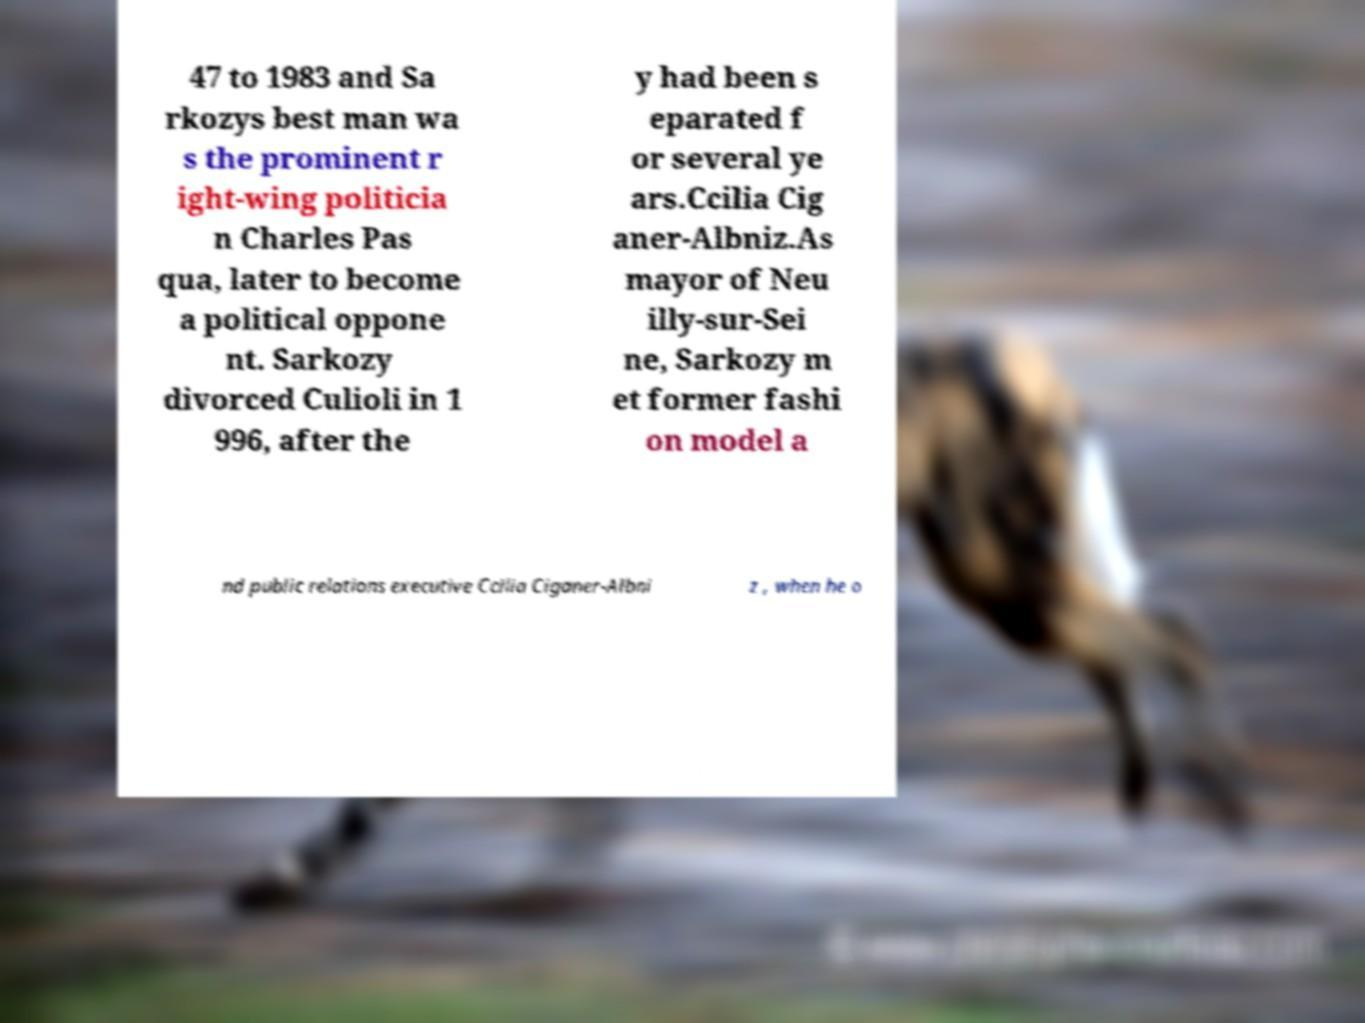Can you accurately transcribe the text from the provided image for me? 47 to 1983 and Sa rkozys best man wa s the prominent r ight-wing politicia n Charles Pas qua, later to become a political oppone nt. Sarkozy divorced Culioli in 1 996, after the y had been s eparated f or several ye ars.Ccilia Cig aner-Albniz.As mayor of Neu illy-sur-Sei ne, Sarkozy m et former fashi on model a nd public relations executive Ccilia Ciganer-Albni z , when he o 